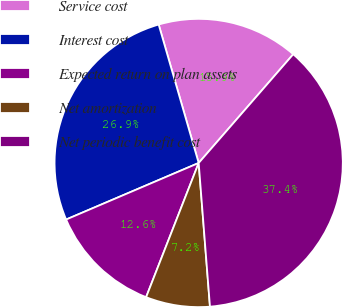Convert chart to OTSL. <chart><loc_0><loc_0><loc_500><loc_500><pie_chart><fcel>Service cost<fcel>Interest cost<fcel>Expected return on plan assets<fcel>Net amortization<fcel>Net periodic benefit cost<nl><fcel>15.87%<fcel>26.94%<fcel>12.64%<fcel>7.19%<fcel>37.36%<nl></chart> 